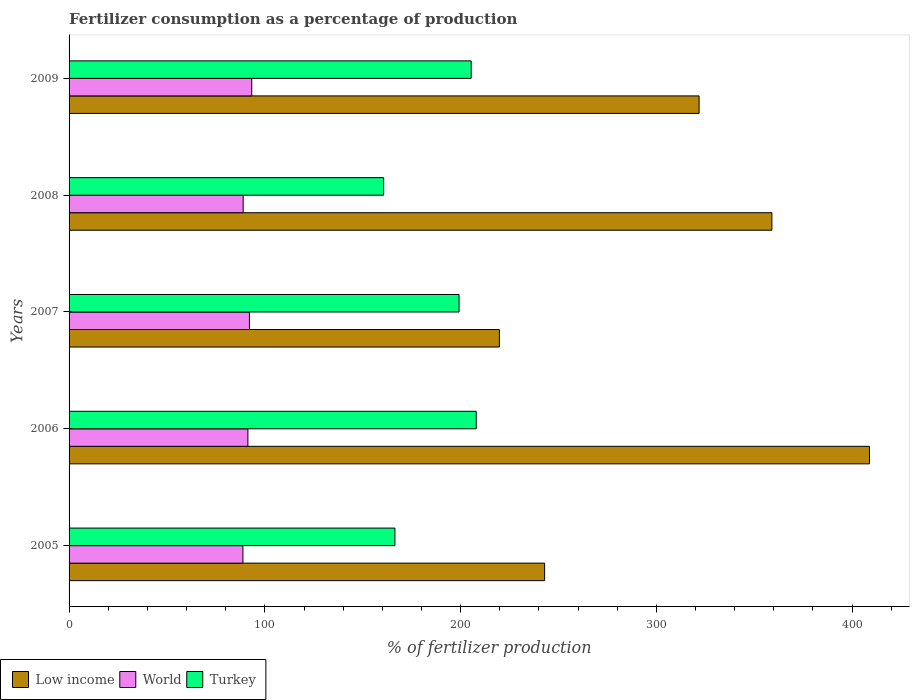Are the number of bars on each tick of the Y-axis equal?
Your answer should be very brief. Yes. How many bars are there on the 3rd tick from the bottom?
Make the answer very short. 3. In how many cases, is the number of bars for a given year not equal to the number of legend labels?
Provide a succinct answer. 0. What is the percentage of fertilizers consumed in Turkey in 2005?
Keep it short and to the point. 166.45. Across all years, what is the maximum percentage of fertilizers consumed in Turkey?
Ensure brevity in your answer.  207.99. Across all years, what is the minimum percentage of fertilizers consumed in Turkey?
Your answer should be compact. 160.7. In which year was the percentage of fertilizers consumed in World maximum?
Your response must be concise. 2009. What is the total percentage of fertilizers consumed in Low income in the graph?
Offer a very short reply. 1552.41. What is the difference between the percentage of fertilizers consumed in World in 2005 and that in 2006?
Provide a short and direct response. -2.53. What is the difference between the percentage of fertilizers consumed in Turkey in 2005 and the percentage of fertilizers consumed in Low income in 2007?
Your response must be concise. -53.36. What is the average percentage of fertilizers consumed in Turkey per year?
Offer a very short reply. 187.95. In the year 2008, what is the difference between the percentage of fertilizers consumed in Turkey and percentage of fertilizers consumed in Low income?
Your response must be concise. -198.31. In how many years, is the percentage of fertilizers consumed in World greater than 240 %?
Ensure brevity in your answer.  0. What is the ratio of the percentage of fertilizers consumed in Turkey in 2006 to that in 2007?
Ensure brevity in your answer.  1.04. Is the percentage of fertilizers consumed in World in 2006 less than that in 2008?
Make the answer very short. No. Is the difference between the percentage of fertilizers consumed in Turkey in 2005 and 2007 greater than the difference between the percentage of fertilizers consumed in Low income in 2005 and 2007?
Your response must be concise. No. What is the difference between the highest and the second highest percentage of fertilizers consumed in World?
Offer a terse response. 1.19. What is the difference between the highest and the lowest percentage of fertilizers consumed in Low income?
Ensure brevity in your answer.  189.04. In how many years, is the percentage of fertilizers consumed in World greater than the average percentage of fertilizers consumed in World taken over all years?
Keep it short and to the point. 3. Is the sum of the percentage of fertilizers consumed in Low income in 2006 and 2007 greater than the maximum percentage of fertilizers consumed in World across all years?
Keep it short and to the point. Yes. Is it the case that in every year, the sum of the percentage of fertilizers consumed in Low income and percentage of fertilizers consumed in World is greater than the percentage of fertilizers consumed in Turkey?
Provide a succinct answer. Yes. Are all the bars in the graph horizontal?
Provide a succinct answer. Yes. What is the difference between two consecutive major ticks on the X-axis?
Offer a very short reply. 100. Where does the legend appear in the graph?
Your answer should be very brief. Bottom left. How many legend labels are there?
Give a very brief answer. 3. What is the title of the graph?
Keep it short and to the point. Fertilizer consumption as a percentage of production. What is the label or title of the X-axis?
Give a very brief answer. % of fertilizer production. What is the % of fertilizer production of Low income in 2005?
Offer a very short reply. 242.91. What is the % of fertilizer production in World in 2005?
Keep it short and to the point. 88.81. What is the % of fertilizer production in Turkey in 2005?
Offer a terse response. 166.45. What is the % of fertilizer production in Low income in 2006?
Keep it short and to the point. 408.85. What is the % of fertilizer production in World in 2006?
Provide a succinct answer. 91.34. What is the % of fertilizer production in Turkey in 2006?
Your response must be concise. 207.99. What is the % of fertilizer production in Low income in 2007?
Give a very brief answer. 219.81. What is the % of fertilizer production of World in 2007?
Your answer should be compact. 92.12. What is the % of fertilizer production in Turkey in 2007?
Provide a succinct answer. 199.21. What is the % of fertilizer production of Low income in 2008?
Your answer should be compact. 359.01. What is the % of fertilizer production in World in 2008?
Your response must be concise. 88.93. What is the % of fertilizer production in Turkey in 2008?
Offer a very short reply. 160.7. What is the % of fertilizer production of Low income in 2009?
Your answer should be compact. 321.82. What is the % of fertilizer production in World in 2009?
Offer a terse response. 93.31. What is the % of fertilizer production in Turkey in 2009?
Make the answer very short. 205.39. Across all years, what is the maximum % of fertilizer production of Low income?
Offer a very short reply. 408.85. Across all years, what is the maximum % of fertilizer production in World?
Provide a succinct answer. 93.31. Across all years, what is the maximum % of fertilizer production in Turkey?
Ensure brevity in your answer.  207.99. Across all years, what is the minimum % of fertilizer production of Low income?
Ensure brevity in your answer.  219.81. Across all years, what is the minimum % of fertilizer production in World?
Provide a succinct answer. 88.81. Across all years, what is the minimum % of fertilizer production in Turkey?
Provide a short and direct response. 160.7. What is the total % of fertilizer production of Low income in the graph?
Your answer should be very brief. 1552.41. What is the total % of fertilizer production in World in the graph?
Ensure brevity in your answer.  454.52. What is the total % of fertilizer production of Turkey in the graph?
Offer a terse response. 939.74. What is the difference between the % of fertilizer production in Low income in 2005 and that in 2006?
Your response must be concise. -165.94. What is the difference between the % of fertilizer production in World in 2005 and that in 2006?
Your response must be concise. -2.54. What is the difference between the % of fertilizer production in Turkey in 2005 and that in 2006?
Your response must be concise. -41.54. What is the difference between the % of fertilizer production of Low income in 2005 and that in 2007?
Provide a succinct answer. 23.1. What is the difference between the % of fertilizer production of World in 2005 and that in 2007?
Provide a succinct answer. -3.32. What is the difference between the % of fertilizer production of Turkey in 2005 and that in 2007?
Provide a short and direct response. -32.76. What is the difference between the % of fertilizer production in Low income in 2005 and that in 2008?
Provide a succinct answer. -116.1. What is the difference between the % of fertilizer production in World in 2005 and that in 2008?
Offer a very short reply. -0.12. What is the difference between the % of fertilizer production in Turkey in 2005 and that in 2008?
Give a very brief answer. 5.75. What is the difference between the % of fertilizer production of Low income in 2005 and that in 2009?
Offer a terse response. -78.91. What is the difference between the % of fertilizer production in World in 2005 and that in 2009?
Offer a terse response. -4.51. What is the difference between the % of fertilizer production of Turkey in 2005 and that in 2009?
Your response must be concise. -38.95. What is the difference between the % of fertilizer production of Low income in 2006 and that in 2007?
Offer a very short reply. 189.04. What is the difference between the % of fertilizer production in World in 2006 and that in 2007?
Ensure brevity in your answer.  -0.78. What is the difference between the % of fertilizer production in Turkey in 2006 and that in 2007?
Keep it short and to the point. 8.78. What is the difference between the % of fertilizer production of Low income in 2006 and that in 2008?
Offer a terse response. 49.84. What is the difference between the % of fertilizer production of World in 2006 and that in 2008?
Your response must be concise. 2.41. What is the difference between the % of fertilizer production in Turkey in 2006 and that in 2008?
Offer a terse response. 47.28. What is the difference between the % of fertilizer production of Low income in 2006 and that in 2009?
Your answer should be very brief. 87.03. What is the difference between the % of fertilizer production in World in 2006 and that in 2009?
Your response must be concise. -1.97. What is the difference between the % of fertilizer production in Turkey in 2006 and that in 2009?
Provide a short and direct response. 2.59. What is the difference between the % of fertilizer production in Low income in 2007 and that in 2008?
Offer a terse response. -139.19. What is the difference between the % of fertilizer production of World in 2007 and that in 2008?
Make the answer very short. 3.19. What is the difference between the % of fertilizer production of Turkey in 2007 and that in 2008?
Provide a short and direct response. 38.5. What is the difference between the % of fertilizer production of Low income in 2007 and that in 2009?
Keep it short and to the point. -102.01. What is the difference between the % of fertilizer production of World in 2007 and that in 2009?
Give a very brief answer. -1.19. What is the difference between the % of fertilizer production in Turkey in 2007 and that in 2009?
Ensure brevity in your answer.  -6.19. What is the difference between the % of fertilizer production in Low income in 2008 and that in 2009?
Provide a short and direct response. 37.19. What is the difference between the % of fertilizer production of World in 2008 and that in 2009?
Your answer should be very brief. -4.38. What is the difference between the % of fertilizer production of Turkey in 2008 and that in 2009?
Your answer should be compact. -44.69. What is the difference between the % of fertilizer production in Low income in 2005 and the % of fertilizer production in World in 2006?
Provide a succinct answer. 151.57. What is the difference between the % of fertilizer production of Low income in 2005 and the % of fertilizer production of Turkey in 2006?
Provide a short and direct response. 34.93. What is the difference between the % of fertilizer production of World in 2005 and the % of fertilizer production of Turkey in 2006?
Provide a short and direct response. -119.18. What is the difference between the % of fertilizer production in Low income in 2005 and the % of fertilizer production in World in 2007?
Your response must be concise. 150.79. What is the difference between the % of fertilizer production of Low income in 2005 and the % of fertilizer production of Turkey in 2007?
Your answer should be compact. 43.71. What is the difference between the % of fertilizer production of World in 2005 and the % of fertilizer production of Turkey in 2007?
Ensure brevity in your answer.  -110.4. What is the difference between the % of fertilizer production in Low income in 2005 and the % of fertilizer production in World in 2008?
Your answer should be very brief. 153.98. What is the difference between the % of fertilizer production of Low income in 2005 and the % of fertilizer production of Turkey in 2008?
Ensure brevity in your answer.  82.21. What is the difference between the % of fertilizer production of World in 2005 and the % of fertilizer production of Turkey in 2008?
Give a very brief answer. -71.89. What is the difference between the % of fertilizer production in Low income in 2005 and the % of fertilizer production in World in 2009?
Your answer should be compact. 149.6. What is the difference between the % of fertilizer production of Low income in 2005 and the % of fertilizer production of Turkey in 2009?
Provide a succinct answer. 37.52. What is the difference between the % of fertilizer production in World in 2005 and the % of fertilizer production in Turkey in 2009?
Offer a very short reply. -116.59. What is the difference between the % of fertilizer production of Low income in 2006 and the % of fertilizer production of World in 2007?
Your answer should be very brief. 316.73. What is the difference between the % of fertilizer production in Low income in 2006 and the % of fertilizer production in Turkey in 2007?
Provide a succinct answer. 209.65. What is the difference between the % of fertilizer production of World in 2006 and the % of fertilizer production of Turkey in 2007?
Provide a short and direct response. -107.86. What is the difference between the % of fertilizer production in Low income in 2006 and the % of fertilizer production in World in 2008?
Offer a very short reply. 319.92. What is the difference between the % of fertilizer production in Low income in 2006 and the % of fertilizer production in Turkey in 2008?
Provide a short and direct response. 248.15. What is the difference between the % of fertilizer production of World in 2006 and the % of fertilizer production of Turkey in 2008?
Give a very brief answer. -69.36. What is the difference between the % of fertilizer production in Low income in 2006 and the % of fertilizer production in World in 2009?
Keep it short and to the point. 315.54. What is the difference between the % of fertilizer production of Low income in 2006 and the % of fertilizer production of Turkey in 2009?
Ensure brevity in your answer.  203.46. What is the difference between the % of fertilizer production in World in 2006 and the % of fertilizer production in Turkey in 2009?
Make the answer very short. -114.05. What is the difference between the % of fertilizer production of Low income in 2007 and the % of fertilizer production of World in 2008?
Give a very brief answer. 130.88. What is the difference between the % of fertilizer production in Low income in 2007 and the % of fertilizer production in Turkey in 2008?
Make the answer very short. 59.11. What is the difference between the % of fertilizer production in World in 2007 and the % of fertilizer production in Turkey in 2008?
Your response must be concise. -68.58. What is the difference between the % of fertilizer production of Low income in 2007 and the % of fertilizer production of World in 2009?
Offer a very short reply. 126.5. What is the difference between the % of fertilizer production of Low income in 2007 and the % of fertilizer production of Turkey in 2009?
Provide a succinct answer. 14.42. What is the difference between the % of fertilizer production of World in 2007 and the % of fertilizer production of Turkey in 2009?
Offer a terse response. -113.27. What is the difference between the % of fertilizer production in Low income in 2008 and the % of fertilizer production in World in 2009?
Make the answer very short. 265.69. What is the difference between the % of fertilizer production of Low income in 2008 and the % of fertilizer production of Turkey in 2009?
Offer a terse response. 153.61. What is the difference between the % of fertilizer production of World in 2008 and the % of fertilizer production of Turkey in 2009?
Keep it short and to the point. -116.46. What is the average % of fertilizer production in Low income per year?
Your response must be concise. 310.48. What is the average % of fertilizer production in World per year?
Provide a succinct answer. 90.9. What is the average % of fertilizer production of Turkey per year?
Give a very brief answer. 187.95. In the year 2005, what is the difference between the % of fertilizer production in Low income and % of fertilizer production in World?
Provide a short and direct response. 154.1. In the year 2005, what is the difference between the % of fertilizer production of Low income and % of fertilizer production of Turkey?
Your answer should be very brief. 76.46. In the year 2005, what is the difference between the % of fertilizer production of World and % of fertilizer production of Turkey?
Provide a succinct answer. -77.64. In the year 2006, what is the difference between the % of fertilizer production of Low income and % of fertilizer production of World?
Your answer should be compact. 317.51. In the year 2006, what is the difference between the % of fertilizer production of Low income and % of fertilizer production of Turkey?
Your response must be concise. 200.87. In the year 2006, what is the difference between the % of fertilizer production of World and % of fertilizer production of Turkey?
Your response must be concise. -116.64. In the year 2007, what is the difference between the % of fertilizer production of Low income and % of fertilizer production of World?
Keep it short and to the point. 127.69. In the year 2007, what is the difference between the % of fertilizer production of Low income and % of fertilizer production of Turkey?
Offer a terse response. 20.61. In the year 2007, what is the difference between the % of fertilizer production in World and % of fertilizer production in Turkey?
Your answer should be very brief. -107.08. In the year 2008, what is the difference between the % of fertilizer production in Low income and % of fertilizer production in World?
Provide a short and direct response. 270.08. In the year 2008, what is the difference between the % of fertilizer production of Low income and % of fertilizer production of Turkey?
Ensure brevity in your answer.  198.31. In the year 2008, what is the difference between the % of fertilizer production of World and % of fertilizer production of Turkey?
Provide a short and direct response. -71.77. In the year 2009, what is the difference between the % of fertilizer production of Low income and % of fertilizer production of World?
Your response must be concise. 228.51. In the year 2009, what is the difference between the % of fertilizer production in Low income and % of fertilizer production in Turkey?
Give a very brief answer. 116.43. In the year 2009, what is the difference between the % of fertilizer production of World and % of fertilizer production of Turkey?
Provide a short and direct response. -112.08. What is the ratio of the % of fertilizer production of Low income in 2005 to that in 2006?
Ensure brevity in your answer.  0.59. What is the ratio of the % of fertilizer production of World in 2005 to that in 2006?
Provide a succinct answer. 0.97. What is the ratio of the % of fertilizer production of Turkey in 2005 to that in 2006?
Provide a short and direct response. 0.8. What is the ratio of the % of fertilizer production in Low income in 2005 to that in 2007?
Keep it short and to the point. 1.11. What is the ratio of the % of fertilizer production in World in 2005 to that in 2007?
Your answer should be compact. 0.96. What is the ratio of the % of fertilizer production in Turkey in 2005 to that in 2007?
Your answer should be compact. 0.84. What is the ratio of the % of fertilizer production in Low income in 2005 to that in 2008?
Your response must be concise. 0.68. What is the ratio of the % of fertilizer production of Turkey in 2005 to that in 2008?
Your response must be concise. 1.04. What is the ratio of the % of fertilizer production in Low income in 2005 to that in 2009?
Offer a terse response. 0.75. What is the ratio of the % of fertilizer production in World in 2005 to that in 2009?
Give a very brief answer. 0.95. What is the ratio of the % of fertilizer production of Turkey in 2005 to that in 2009?
Your answer should be compact. 0.81. What is the ratio of the % of fertilizer production in Low income in 2006 to that in 2007?
Provide a short and direct response. 1.86. What is the ratio of the % of fertilizer production of World in 2006 to that in 2007?
Provide a short and direct response. 0.99. What is the ratio of the % of fertilizer production of Turkey in 2006 to that in 2007?
Provide a short and direct response. 1.04. What is the ratio of the % of fertilizer production in Low income in 2006 to that in 2008?
Your response must be concise. 1.14. What is the ratio of the % of fertilizer production of World in 2006 to that in 2008?
Make the answer very short. 1.03. What is the ratio of the % of fertilizer production of Turkey in 2006 to that in 2008?
Provide a short and direct response. 1.29. What is the ratio of the % of fertilizer production of Low income in 2006 to that in 2009?
Offer a very short reply. 1.27. What is the ratio of the % of fertilizer production in World in 2006 to that in 2009?
Offer a very short reply. 0.98. What is the ratio of the % of fertilizer production in Turkey in 2006 to that in 2009?
Offer a terse response. 1.01. What is the ratio of the % of fertilizer production of Low income in 2007 to that in 2008?
Your answer should be compact. 0.61. What is the ratio of the % of fertilizer production of World in 2007 to that in 2008?
Keep it short and to the point. 1.04. What is the ratio of the % of fertilizer production of Turkey in 2007 to that in 2008?
Offer a very short reply. 1.24. What is the ratio of the % of fertilizer production of Low income in 2007 to that in 2009?
Provide a short and direct response. 0.68. What is the ratio of the % of fertilizer production in World in 2007 to that in 2009?
Ensure brevity in your answer.  0.99. What is the ratio of the % of fertilizer production of Turkey in 2007 to that in 2009?
Your answer should be very brief. 0.97. What is the ratio of the % of fertilizer production of Low income in 2008 to that in 2009?
Offer a terse response. 1.12. What is the ratio of the % of fertilizer production in World in 2008 to that in 2009?
Keep it short and to the point. 0.95. What is the ratio of the % of fertilizer production in Turkey in 2008 to that in 2009?
Your response must be concise. 0.78. What is the difference between the highest and the second highest % of fertilizer production in Low income?
Provide a succinct answer. 49.84. What is the difference between the highest and the second highest % of fertilizer production in World?
Ensure brevity in your answer.  1.19. What is the difference between the highest and the second highest % of fertilizer production of Turkey?
Offer a very short reply. 2.59. What is the difference between the highest and the lowest % of fertilizer production of Low income?
Your answer should be compact. 189.04. What is the difference between the highest and the lowest % of fertilizer production of World?
Your answer should be very brief. 4.51. What is the difference between the highest and the lowest % of fertilizer production of Turkey?
Offer a terse response. 47.28. 